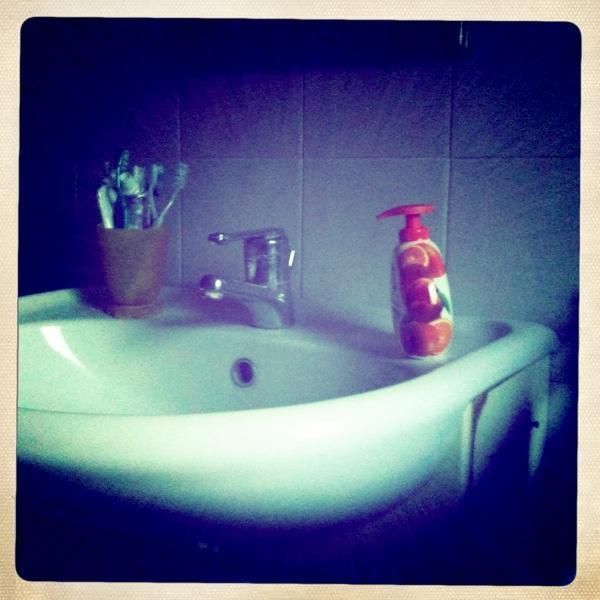How many people are wearing cap?
Give a very brief answer. 0. 